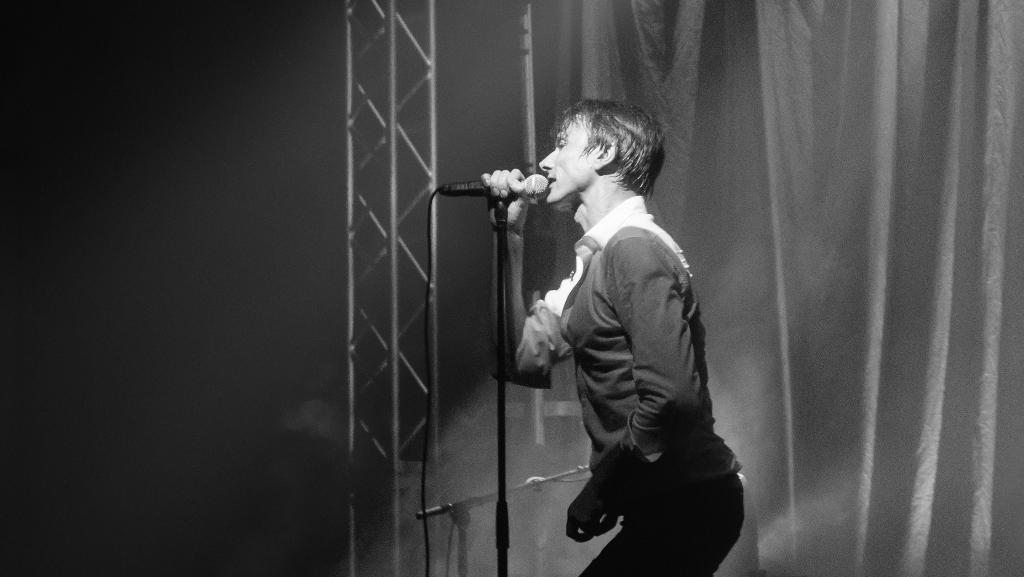Please provide a concise description of this image. In is a black and white image. In this image we can see a man standing and holding the mike. We can also see some rods and also the curtain and smoke in the background. On the left we can see the plain background. 